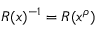Convert formula to latex. <formula><loc_0><loc_0><loc_500><loc_500>R ( x ) ^ { - 1 } = R ( x ^ { \rho } )</formula> 